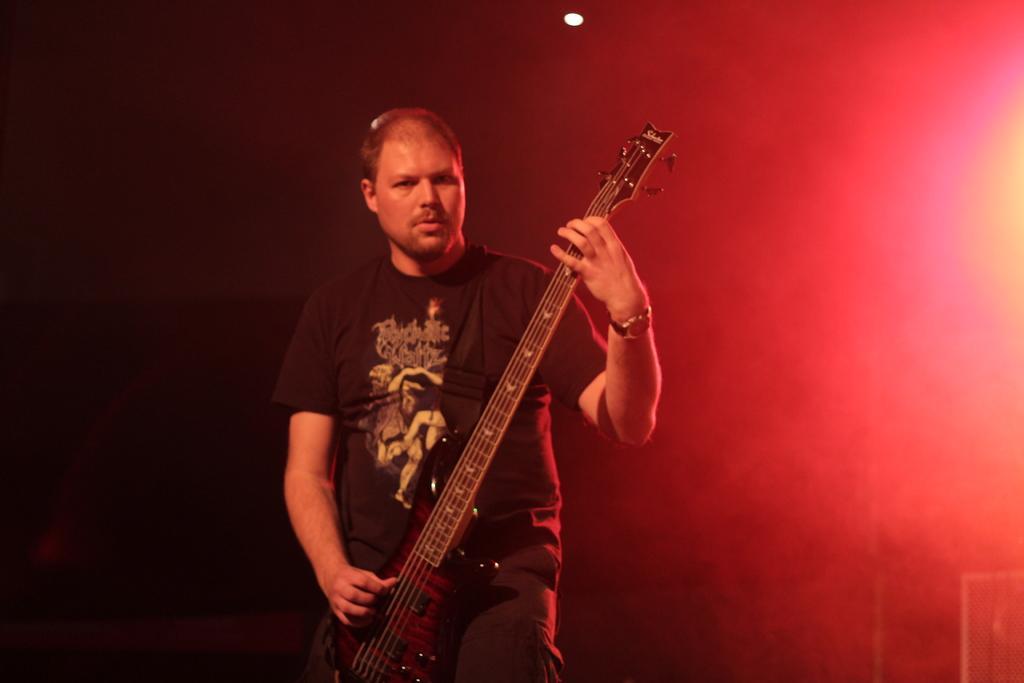How would you summarize this image in a sentence or two? In this image, In the middle there is a man standing and holding a music instrument and he is wearing is a watch in his left hand which is in black color, In the background there is a red color and black color wall. 